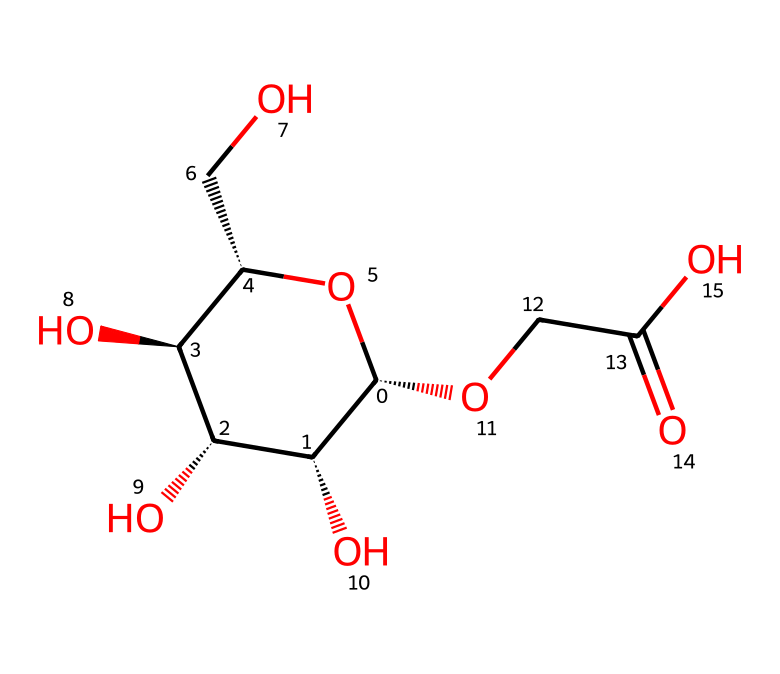What is the primary function of carboxymethyl cellulose? Carboxymethyl cellulose (CMC) is primarily used as a thickening agent in food products. Its structure, characterized by the various hydroxyl (OH) groups, contributes to its ability to increase viscosity.
Answer: thickening agent How many hydroxyl groups are present in the structure of CMC? By analyzing the chemical structure, the presence of hydroxyl (OH) groups is evident at multiple locations. Counting these reveals there are four hydroxyl groups.
Answer: four Is CMC a natural or synthetic additive? The structure of CMC indicates that it is derived from cellulose, a natural polymer, but the modification to create carboxymethyl cellulose makes it classified as a synthetic additive.
Answer: synthetic What type of chemical compound is represented here? The molecular structure shows functional groups typically associated with polysaccharides and cellulose derivatives, categorizing CMC as a carbohydrate or polysaccharide.
Answer: polysaccharide What functional group is primarily responsible for the thickening properties of CMC? The carboxymethyl group (–COOH) primarily contributes to the thickening properties, enabling CMC to interact with water and increase viscosity.
Answer: carboxymethyl group How many carbon atoms are in the structure of CMC? By examining the structure, the number of carbon atoms can be counted: there are nine carbons in total.
Answer: nine 